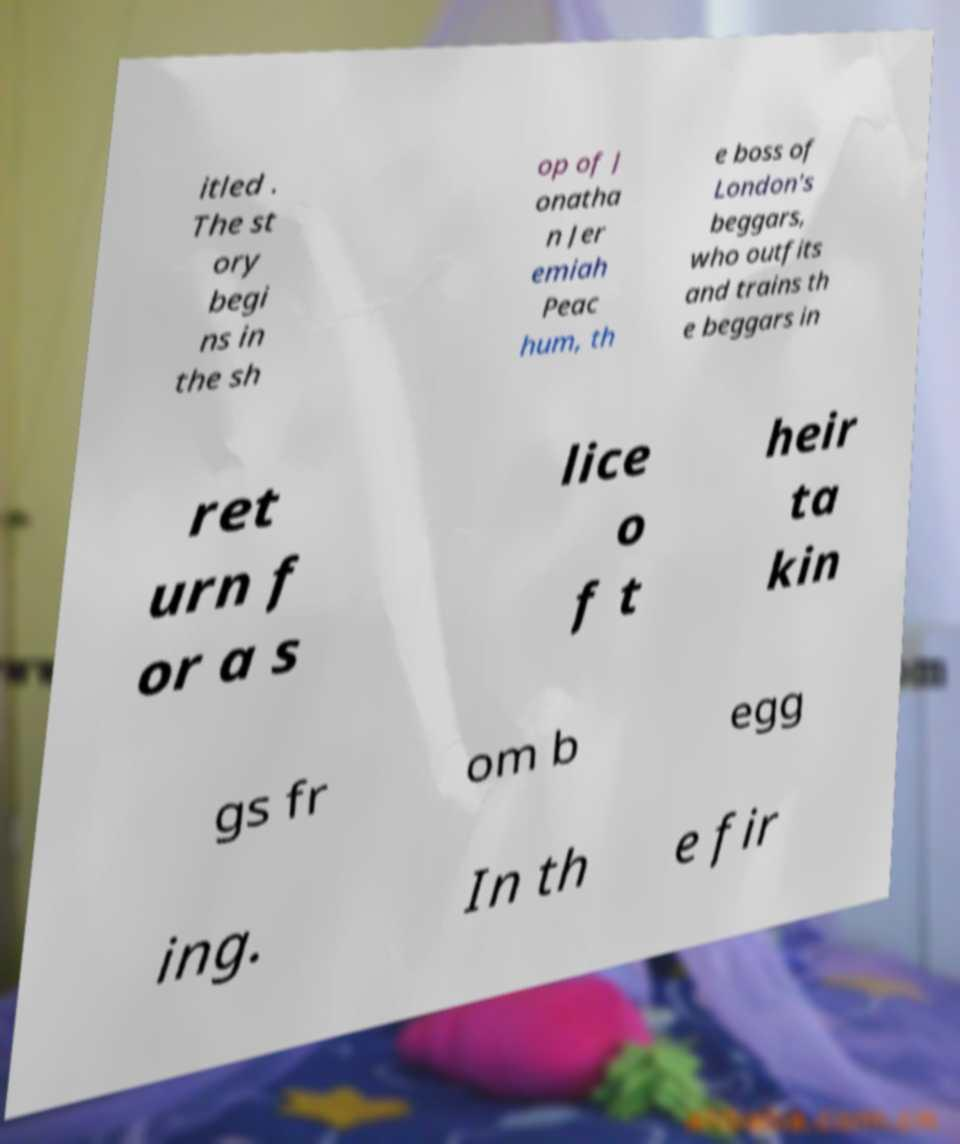Could you extract and type out the text from this image? itled . The st ory begi ns in the sh op of J onatha n Jer emiah Peac hum, th e boss of London's beggars, who outfits and trains th e beggars in ret urn f or a s lice o f t heir ta kin gs fr om b egg ing. In th e fir 